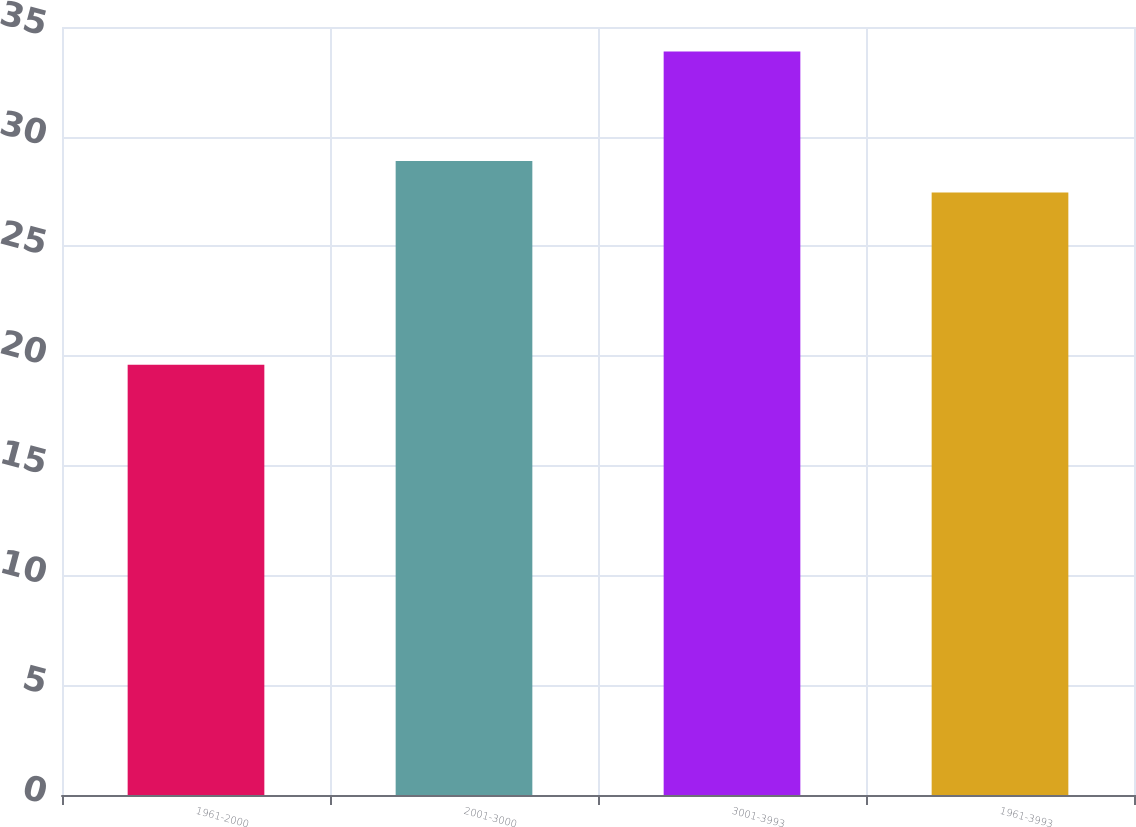Convert chart to OTSL. <chart><loc_0><loc_0><loc_500><loc_500><bar_chart><fcel>1961-2000<fcel>2001-3000<fcel>3001-3993<fcel>1961-3993<nl><fcel>19.61<fcel>28.89<fcel>33.88<fcel>27.46<nl></chart> 